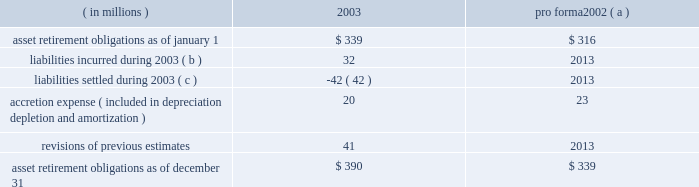New accounting standards effective january 1 , 2003 , marathon adopted statement of financial accounting standards no .
143 201caccounting for asset retirement obligations 201d ( 201csfas no .
143 201d ) .
This statement requires that the fair value of an asset retirement obligation be recognized in the period in which it is incurred if a reasonable estimate of fair value can be made .
The present value of the estimated asset retirement cost is capitalized as part of the carrying amount of the long-lived asset .
Previous accounting standards used the units-of-production method to match estimated future retirement costs with the revenues generated from the producing assets .
In contrast , sfas no .
143 requires depreciation of the capitalized asset retirement cost and accretion of the asset retirement obligation over time .
The depreciation will generally be determined on a units-of-production basis over the life of the field , while the accretion to be recognized will escalate over the life of the producing assets , typically as production declines .
For marathon , asset retirement obligations primarily relate to the abandonment of oil and gas producing facilities .
While assets such as refineries , crude oil and product pipelines , and marketing assets have retirement obligations covered by sfas no .
143 , certain of those obligations are not recognized since the fair value cannot be estimated due to the uncertainty of the settlement date of the obligation .
The transition adjustment related to adopting sfas no .
143 on january 1 , 2003 , was recognized as a cumulative effect of a change in accounting principle .
The cumulative effect on net income of adopting sfas no .
143 was a net favorable effect of $ 4 million , net of tax of $ 4 million .
At the time of adoption , total assets increased $ 120 million , and total liabilities increased $ 116 million .
The amounts recognized upon adoption are based upon numerous estimates and assumptions , including future retirement costs , future recoverable quantities of oil and gas , future inflation rates and the credit-adjusted risk-free interest rate .
Changes in asset retirement obligations during the year were : ( in millions ) 2003 pro forma 2002 ( a ) .
( a ) pro forma data as if sfas no .
143 had been adopted on january 1 , 2002 .
If adopted , income before cumulative effect of changes in accounting principles for 2002 would have been increased by $ 1 million and there would have been no impact on earnings per share .
( b ) includes $ 12 million related to the acquisition of khanty mansiysk oil corporation in 2003 .
( c ) includes $ 25 million associated with assets sold in 2003 .
In the second quarter of 2002 , the financial accounting standards board ( 201cfasb 201d ) issued statement of financial accounting standards no .
145 201crescission of fasb statements no .
4 , 44 , and 64 , amendment of fasb statement no .
13 , and technical corrections 201d ( 201csfas no .
145 201d ) .
Effective january 1 , 2003 , marathon adopted the provisions relating to the classification of the effects of early extinguishment of debt in the consolidated statement of income .
As a result , losses of $ 53 million from the early extinguishment of debt in 2002 , which were previously reported as an extraordinary item ( net of tax of $ 20 million ) , have been reclassified into income before income taxes .
The adoption of sfas no .
145 had no impact on net income for 2002 .
Effective january 1 , 2003 , marathon adopted statement of financial accounting standards no .
146 201caccounting for exit or disposal activities 201d ( 201csfas no .
146 201d ) .
Sfas no .
146 is effective for exit or disposal activities that are initiated after december 31 , 2002 .
There were no impacts upon the initial adoption of sfas no .
146 .
Effective january 1 , 2003 , marathon adopted the fair value recognition provisions of statement of financial accounting standards no .
123 201caccounting for stock-based compensation 201d ( 201csfas no .
123 201d ) .
Statement of financial accounting standards no .
148 201caccounting for stock-based compensation 2013 transition and disclosure 201d ( 201csfas no .
148 201d ) , an amendment of sfas no .
123 , provides alternative methods for the transition of the accounting for stock-based compensation from the intrinsic value method to the fair value method .
Marathon has applied the fair value method to grants made , modified or settled on or after january 1 , 2003 .
The impact on marathon 2019s 2003 net income was not materially different than under previous accounting standards .
The fasb issued statement of financial accounting standards no .
149 201camendment of statement 133 on derivative instruments and hedging activities 201d on april 30 , 2003 .
The statement is effective for derivative contracts entered into or modified after june 30 , 2003 and for hedging relationships designated after june 30 , 2003 .
The adoption of this statement did not have an effect on marathon 2019s financial position , cash flows or results of operations .
The fasb issued statement of financial accounting standards no .
150 201caccounting for certain financial instruments with characteristics of both liabilities and equity 201d on may 30 , 2003 .
The adoption of this statement , effective july 1 , 2003 , did not have a material effect on marathon 2019s financial position or results of operations .
Effective january 1 , 2003 , fasb interpretation no .
45 , 201cguarantor 2019s accounting and disclosure requirements for guarantees , including indirect guarantees of indebtedness of others 201d ( 201cfin 45 201d ) , requires the fair-value .
What are total asset retirement obligations as of december 31 2002 and 2003 , in millions? 
Computations: (390 + 339)
Answer: 729.0. 